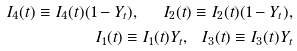Convert formula to latex. <formula><loc_0><loc_0><loc_500><loc_500>I _ { 4 } ( t ) \equiv I _ { 4 } ( t ) ( 1 - Y _ { t } ) , \ \ I _ { 2 } ( t ) \equiv I _ { 2 } ( t ) ( 1 - Y _ { t } ) , \\ I _ { 1 } ( t ) \equiv I _ { 1 } ( t ) Y _ { t } , \ \ I _ { 3 } ( t ) \equiv I _ { 3 } ( t ) Y _ { t }</formula> 